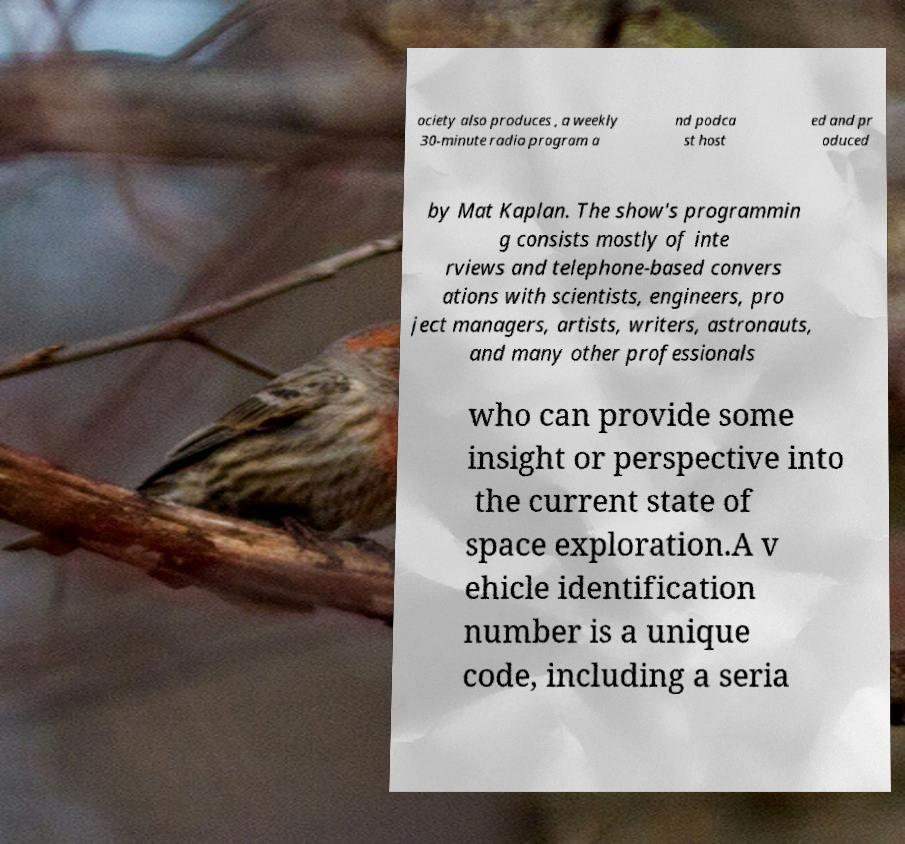There's text embedded in this image that I need extracted. Can you transcribe it verbatim? ociety also produces , a weekly 30-minute radio program a nd podca st host ed and pr oduced by Mat Kaplan. The show's programmin g consists mostly of inte rviews and telephone-based convers ations with scientists, engineers, pro ject managers, artists, writers, astronauts, and many other professionals who can provide some insight or perspective into the current state of space exploration.A v ehicle identification number is a unique code, including a seria 